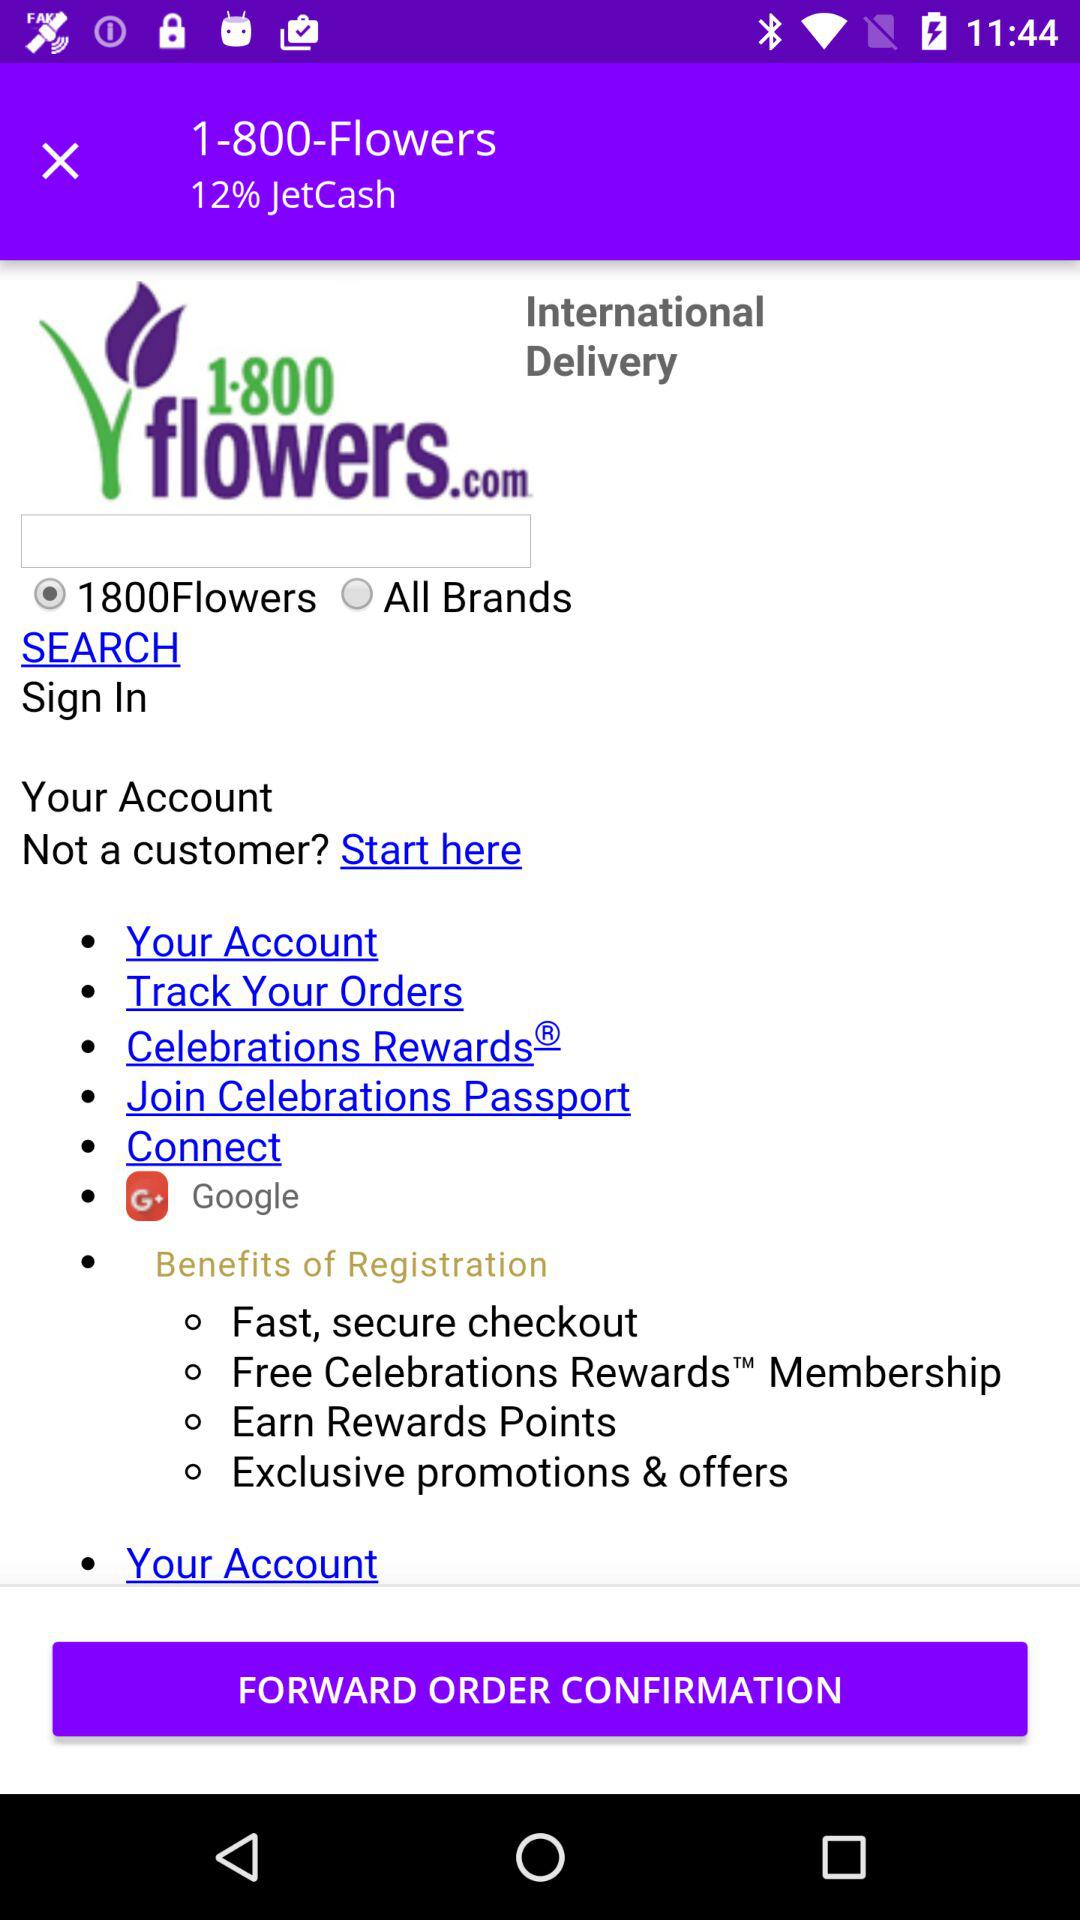What are the benefits of registration? The benefits of registration are "Fast, secure checkout", "Free Celebrations Rewards Membership", "Earn Rewards Points" and "Exclusive promotions & offers". 